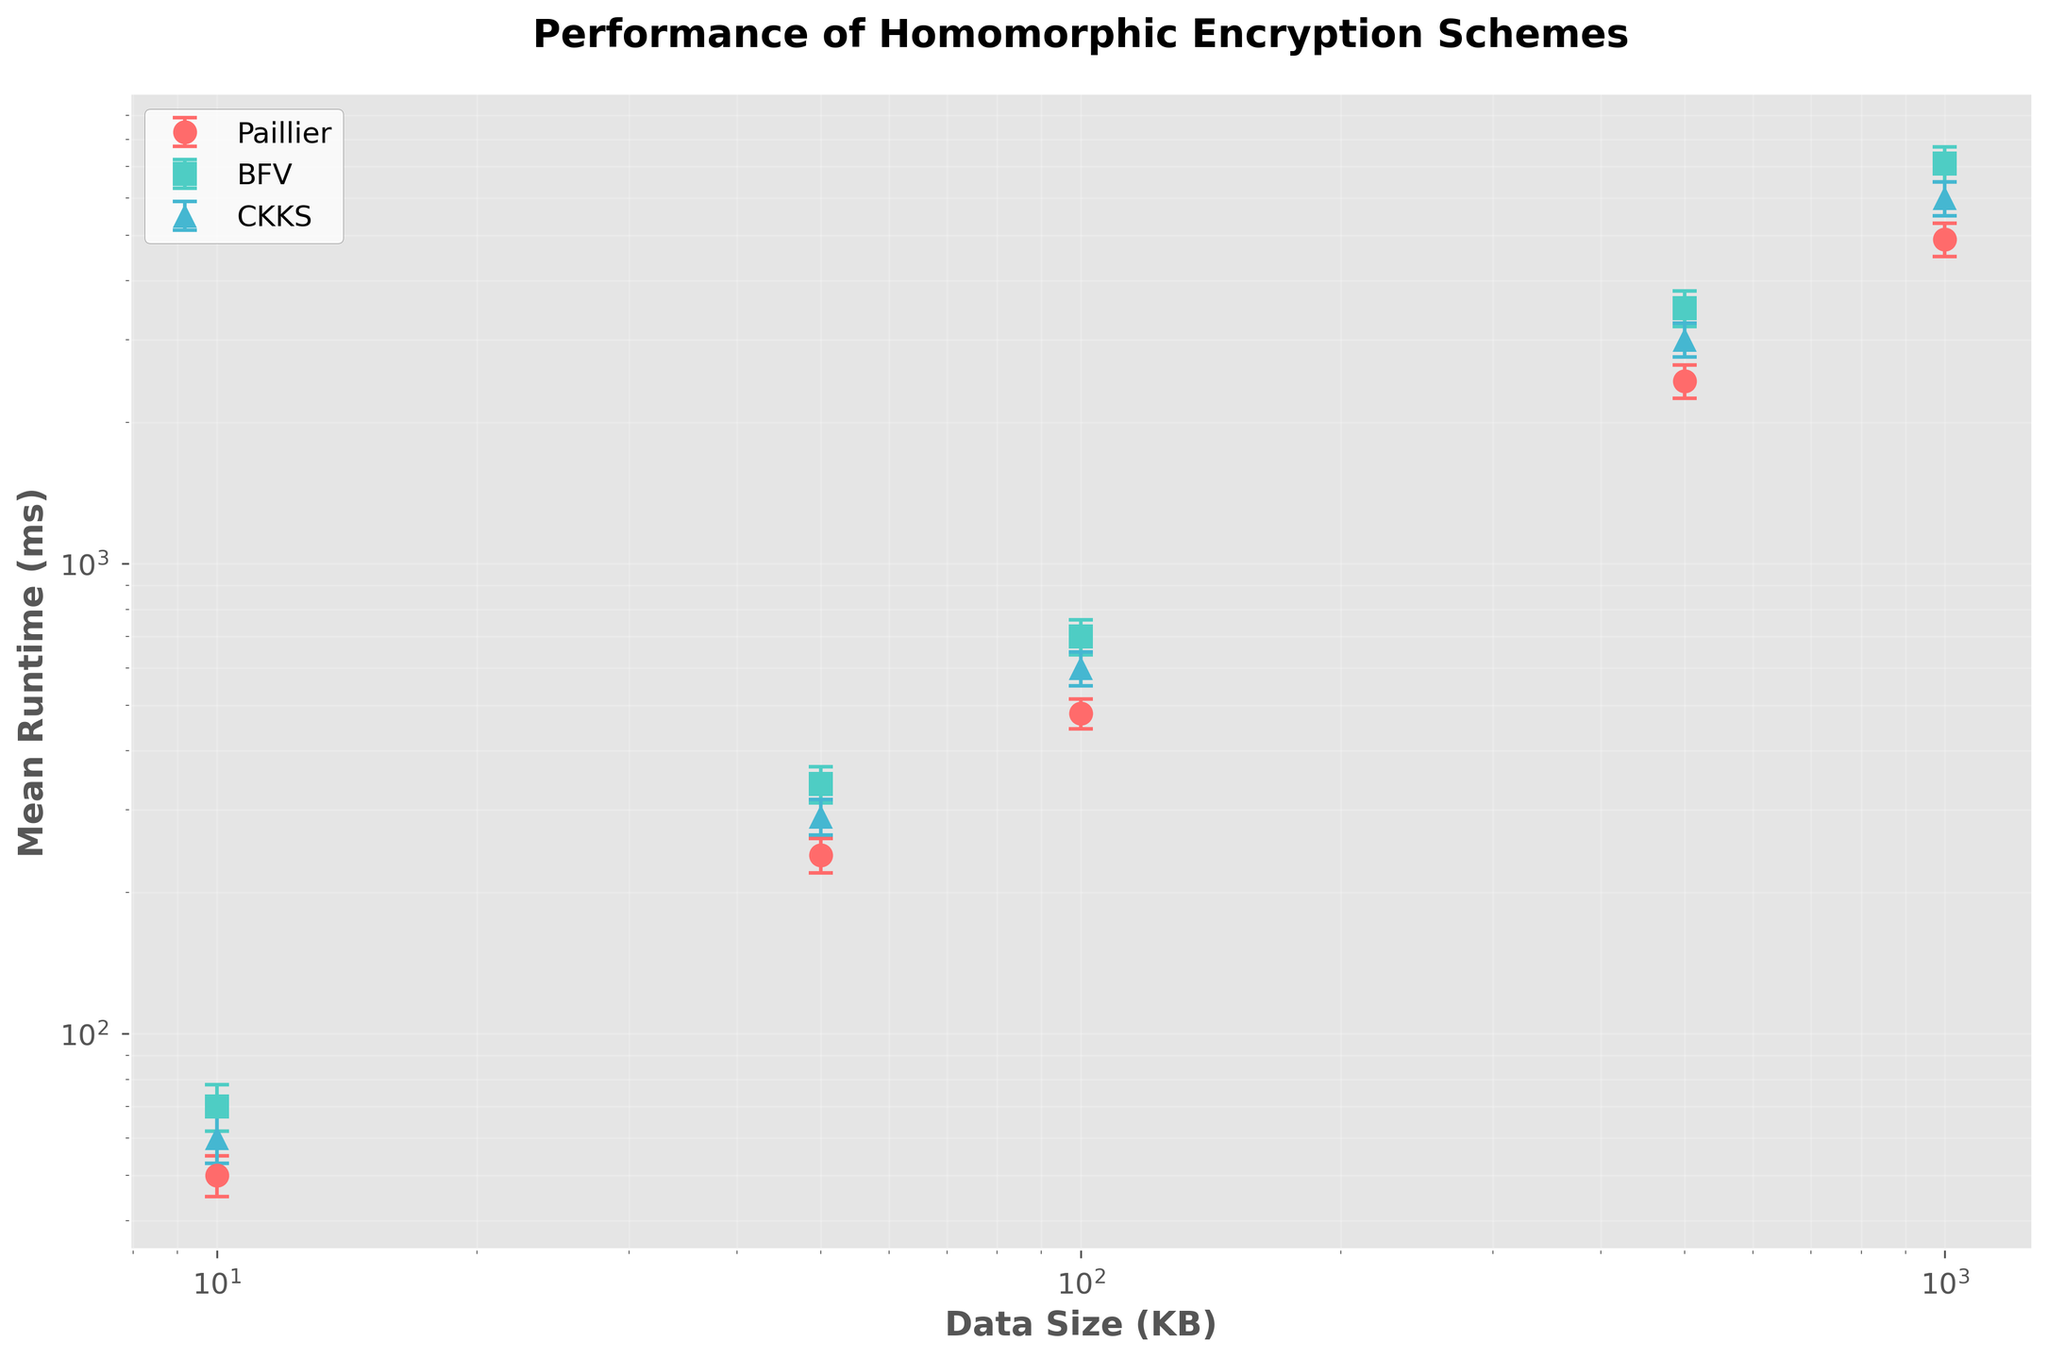Which encryption scheme has the lowest mean runtime for the smallest data size? Referring to the figure, for a data size of 10 KB, we compare the mean runtimes of the three schemes. Paillier has a mean runtime of 50 ms, BFV has 70 ms, and CKKS has 60 ms. Hence, Paillier has the lowest mean runtime.
Answer: Paillier What is the difference in mean runtime between the Paillier and CKKS schemes for a data size of 50 KB? Referring to the figure, for 50 KB, Paillier has a mean runtime of 240 ms and CKKS has 290 ms. The difference is 290 ms - 240 ms = 50 ms.
Answer: 50 ms Which scheme shows the highest variability in mean runtime for a data size of 1000 KB? To determine this, we look at the error bars for 1000 KB data size. Paillier has an error of 400 ms, BFV has 600 ms, and CKKS has 500 ms. Thus, BFV shows the highest variability.
Answer: BFV How does the mean runtime of the BFV scheme compare to the CKKS scheme for data sizes above 100 KB? BFV's mean runtimes for 100, 500, and 1000 KB are 700 ms, 3500 ms, and 7100 ms. CKKS's mean runtimes for the same sizes are 600 ms, 3000 ms, and 6000 ms. BFV’s mean runtimes are consistently higher than CKKS for these sizes.
Answer: BFV is higher What is the mean runtime ratio of the BFV to Paillier schemes for a data size of 500 KB? At 500 KB, BFV has a mean runtime of 3500 ms and Paillier has 2450 ms. The ratio is 3500 ms / 2450 ms ≈ 1.43.
Answer: 1.43 Which scheme shows the smallest increase in mean runtime when the data size increases from 50 KB to 100 KB? Paillier's increase is 480 ms - 240 ms = 240 ms. BFV's increase is 700 ms - 340 ms = 360 ms. CKKS's increase is 600 ms - 290 ms = 310 ms. Thus, Paillier shows the smallest increase.
Answer: Paillier At which data size do the Paillier and CKKS schemes show similar mean runtimes? Referring to the figure, the mean runtimes of Paillier and CKKS are closest at 100 KB, where Paillier is 480 ms and CKKS is 600 ms.
Answer: 100 KB How do the error bars for the BFV scheme at 500 KB compare to those at 1000 KB? At 500 KB, the error is 300 ms. At 1000 KB, the error is 600 ms. The error at 1000 KB is twice as large as at 500 KB.
Answer: 1000 KB is twice as large What's the overall trend in mean runtimes as data sizes increase for all schemes? Referring to the figure, for all schemes (Paillier, BFV, and CKKS), the mean runtimes increase as data sizes increase.
Answer: Increase 